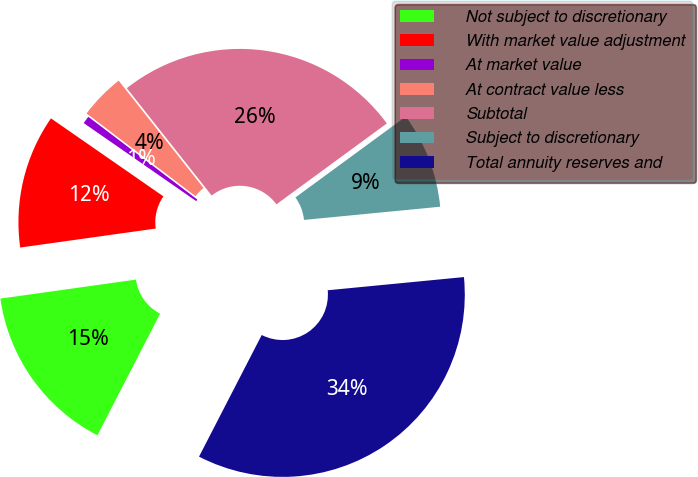<chart> <loc_0><loc_0><loc_500><loc_500><pie_chart><fcel>Not subject to discretionary<fcel>With market value adjustment<fcel>At market value<fcel>At contract value less<fcel>Subtotal<fcel>Subject to discretionary<fcel>Total annuity reserves and<nl><fcel>15.21%<fcel>11.87%<fcel>0.68%<fcel>4.02%<fcel>25.58%<fcel>8.53%<fcel>34.11%<nl></chart> 